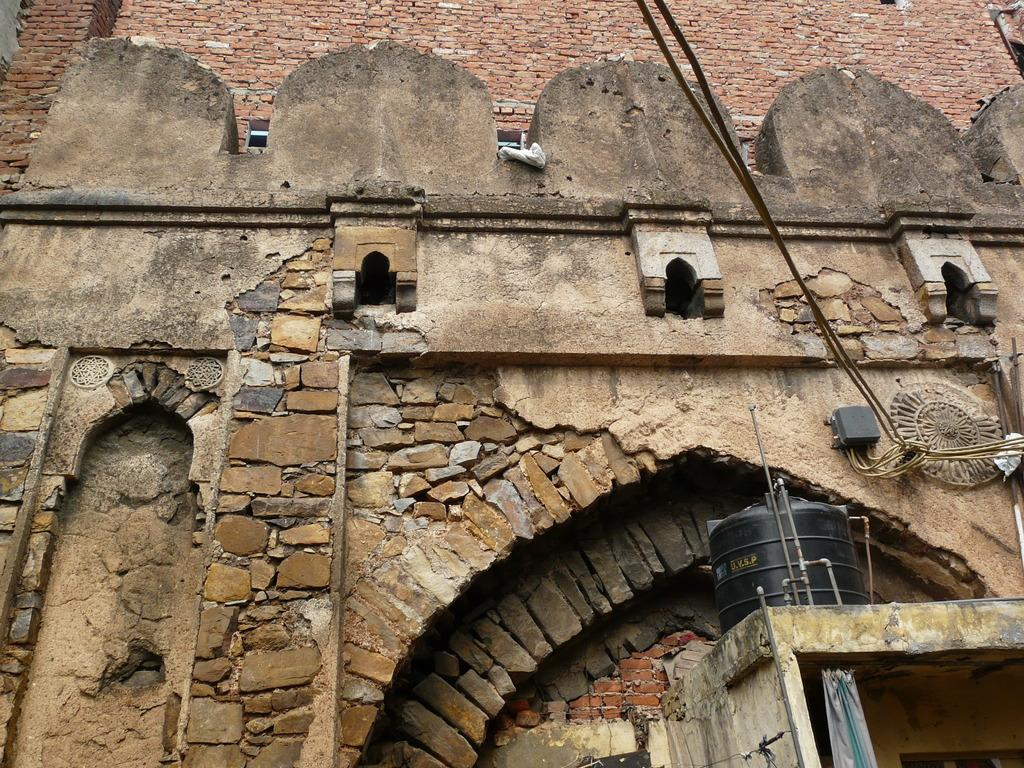What is the main structure in the center of the image? There is a building in the center of the image. What can be seen on the right side of the image? There is a water tank, pipes, cloth, and rope on the right side of the image. What is visible in the background of the image? There is a wall in the background of the image. How many knots are tied in the rope in the image? There is no information about knots in the rope in the image, as it only mentions the presence of rope. What type of poison is being used to clean the water tank in the image? There is no mention of poison or any cleaning activity involving the water tank in the image. 